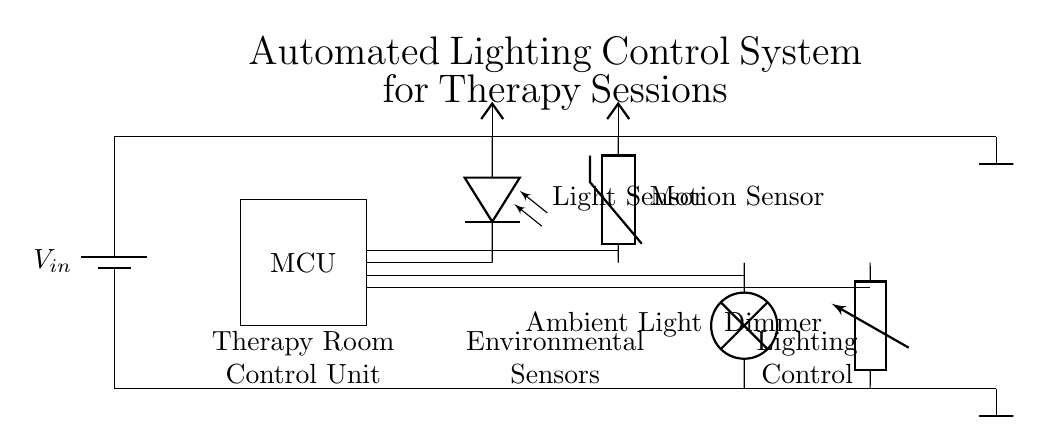What is the main component of this circuit? The main component is the microcontroller, indicated by the rectangular shape labeled "MCU." It is responsible for processing sensor inputs and controlling outputs.
Answer: microcontroller How many sensors are present in the circuit? There are two sensors present: a light sensor and a motion sensor. They are both represented with their respective labels in the diagram and are connected to the microcontroller for input data processing.
Answer: two What type of lighting control is included? The circuit includes a dimmer circuit as indicated by the labeled component "Dimmer." This allows for adjustable brightness of the ambient lighting based on sensor feedback.
Answer: dimmer Which component provides power to the circuit? The power source is provided by the battery as indicated by the component labeled "V_in." This supplies the necessary voltage for the entire circuit operation.
Answer: battery How do the light and motion sensors influence the lighting control? The light sensor detects ambient light levels and the motion sensor detects presence. Their outputs are processed by the microcontroller, which adjusts the dimmer settings to modify the lighting accordingly, creating a comfortable ambiance for therapy.
Answer: by adjusting the dimmer What is the purpose of the ambient light in this circuit? The ambient light component is designated to create a soothing environment within the therapy room, essential for effective counseling sessions. Its brightness can be adjusted continuously based on sensor inputs to suit different therapy needs.
Answer: to create ambiance 